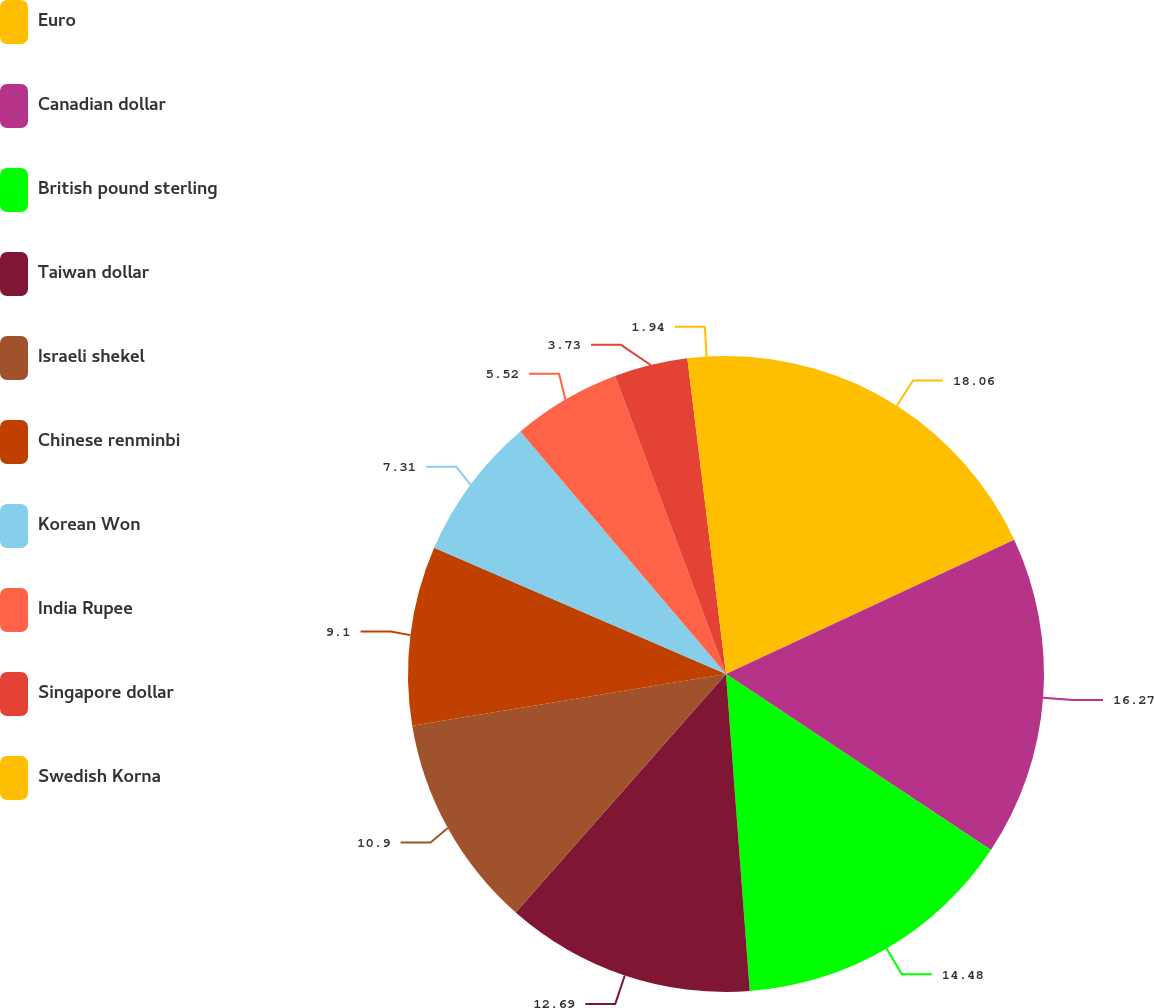Convert chart. <chart><loc_0><loc_0><loc_500><loc_500><pie_chart><fcel>Euro<fcel>Canadian dollar<fcel>British pound sterling<fcel>Taiwan dollar<fcel>Israeli shekel<fcel>Chinese renminbi<fcel>Korean Won<fcel>India Rupee<fcel>Singapore dollar<fcel>Swedish Korna<nl><fcel>18.06%<fcel>16.27%<fcel>14.48%<fcel>12.69%<fcel>10.9%<fcel>9.1%<fcel>7.31%<fcel>5.52%<fcel>3.73%<fcel>1.94%<nl></chart> 